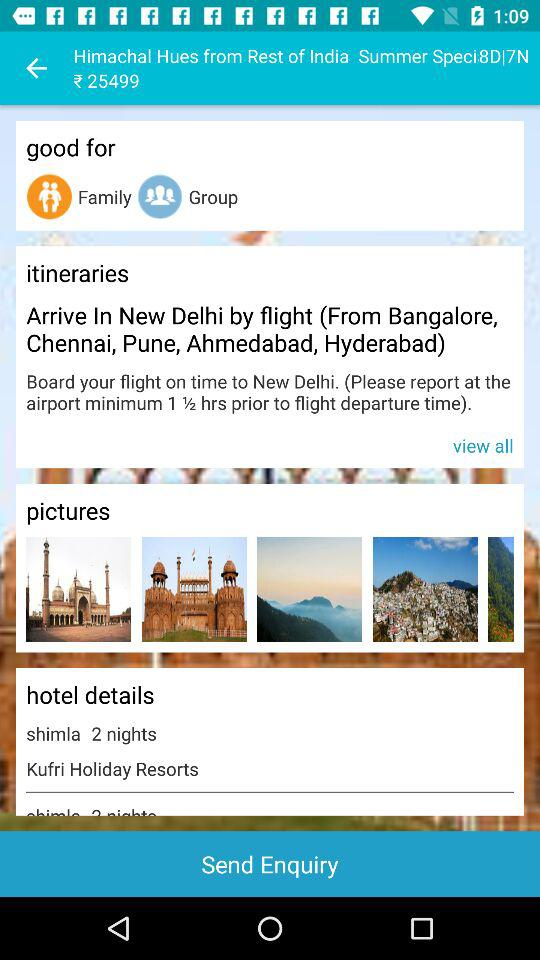How many hours prior to the flight departure time does one need to report at the airport? One needs to report an hour and a half prior to the flight departure time. 